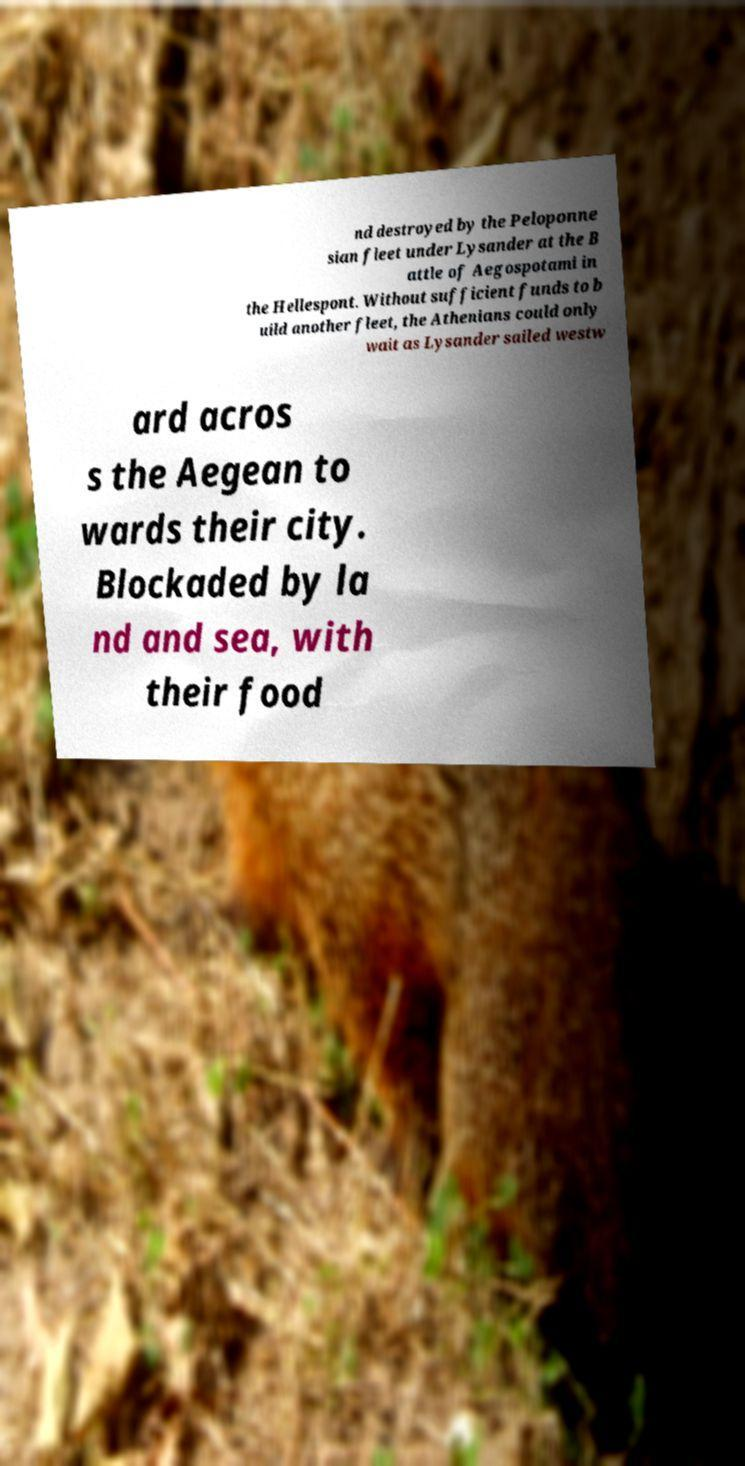For documentation purposes, I need the text within this image transcribed. Could you provide that? nd destroyed by the Peloponne sian fleet under Lysander at the B attle of Aegospotami in the Hellespont. Without sufficient funds to b uild another fleet, the Athenians could only wait as Lysander sailed westw ard acros s the Aegean to wards their city. Blockaded by la nd and sea, with their food 